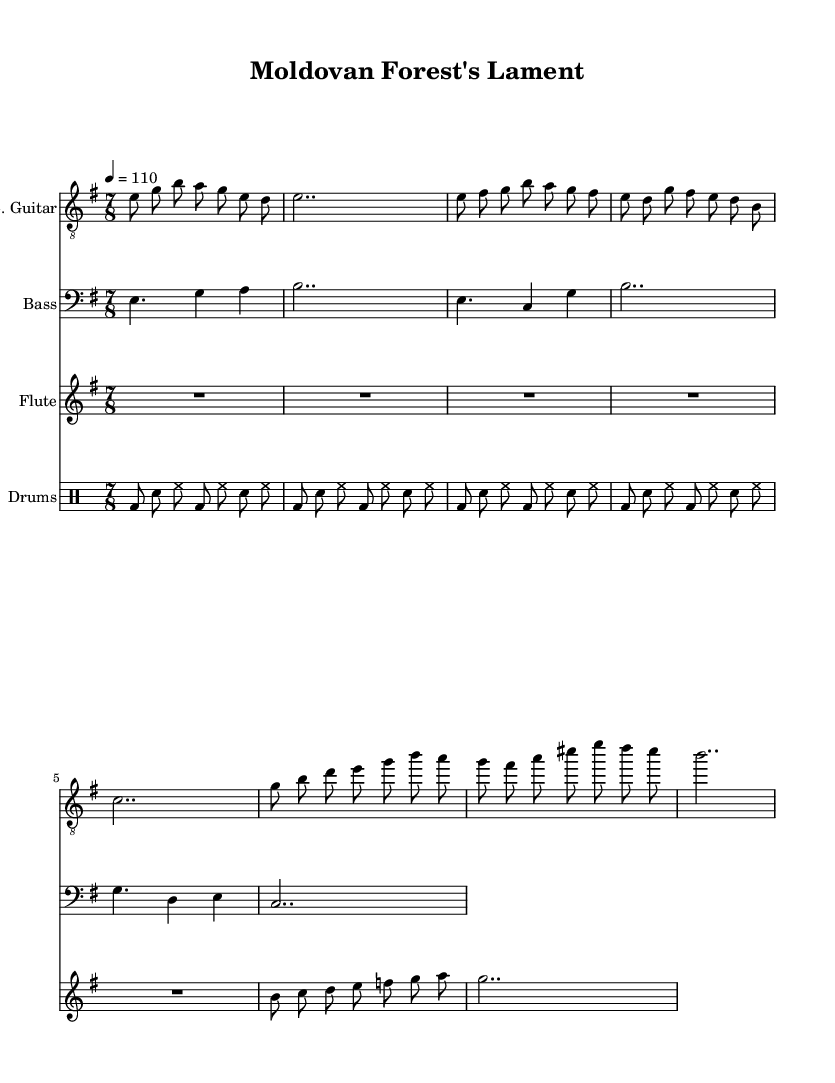What is the key signature of this music? The key signature is indicated at the beginning of the staff, where it shows E minor, which features one sharp (F#).
Answer: E minor What is the time signature of this music? The time signature is displayed at the start of the piece, where it shows 7/8, meaning there are seven eighth notes per measure.
Answer: 7/8 What is the tempo marking in this music? The tempo marking can be found in the header as "4 = 110", which indicates a quarter note is played at a speed of 110 beats per minute.
Answer: 110 What is the instrument playing the melody in the intro? The melody in the intro is played by the electric guitar, as specified by the staff notation that uses the clef for guitar notation.
Answer: Electric Guitar How many measures are in the chorus section? To determine this, we look through the musical section labeled as "Chorus" and count the measures where the notes are present. There are four measures in total for the chorus.
Answer: 4 What is the rhythmic pattern of the drums in the drums part? The drums part consists of a consistent pattern described as bass drum, snare, hi-hat, repeating throughout the section, showing a typical rock rhythm pattern.
Answer: Bass drum, snare, hi-hat What is the highest note in the flute part during the chorus? In the flute part of the chorus, the notes range from b up to g, which is the highest note the flute reaches in that section.
Answer: g 